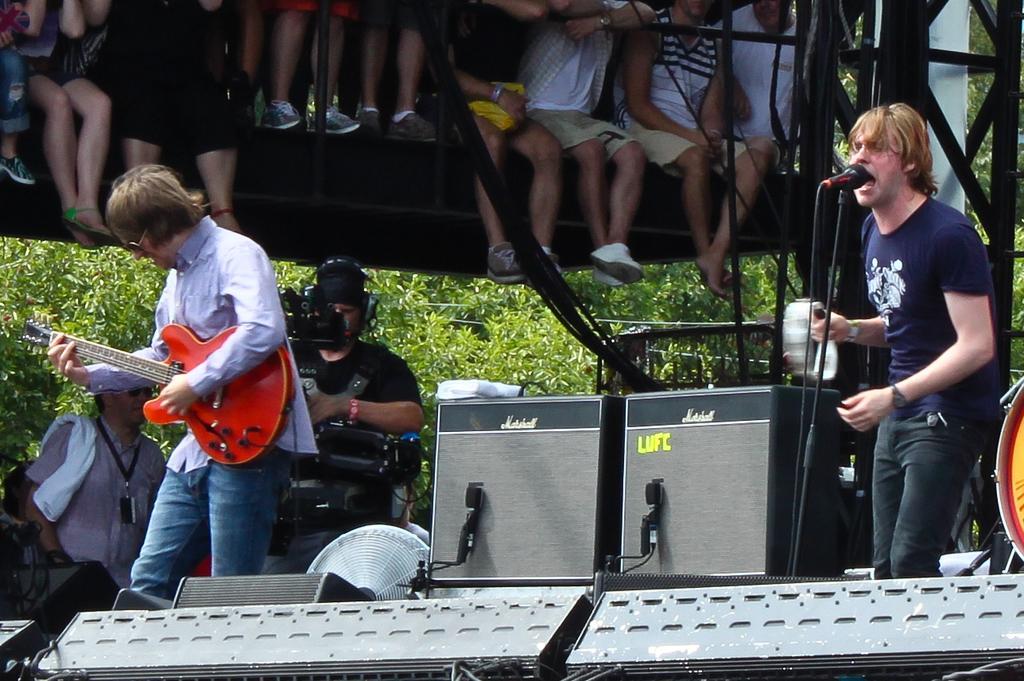How would you summarize this image in a sentence or two? On the background we can see persons sitting and standing on platform. Here we can see one man standing near to the mike and singing. Here we can see a man wearing goggles and playing a guitar. These are plants. We can this man wearing headsets and recording through a cam recorder. We can see one man standing and wearing id card and we can see a cloth on his shoulder. These are devices. 